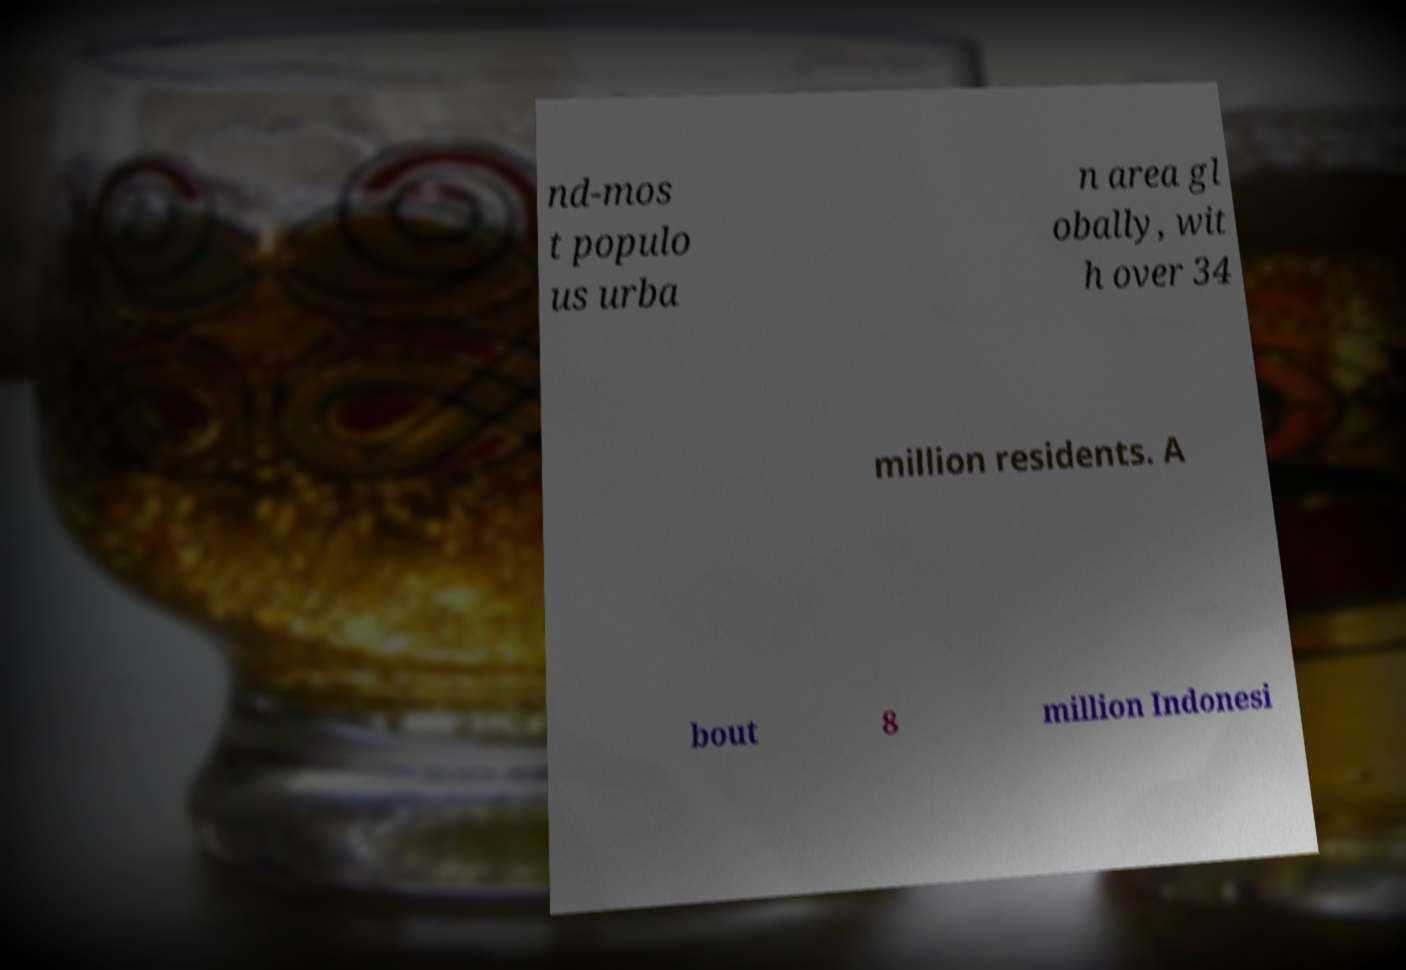Can you read and provide the text displayed in the image?This photo seems to have some interesting text. Can you extract and type it out for me? nd-mos t populo us urba n area gl obally, wit h over 34 million residents. A bout 8 million Indonesi 